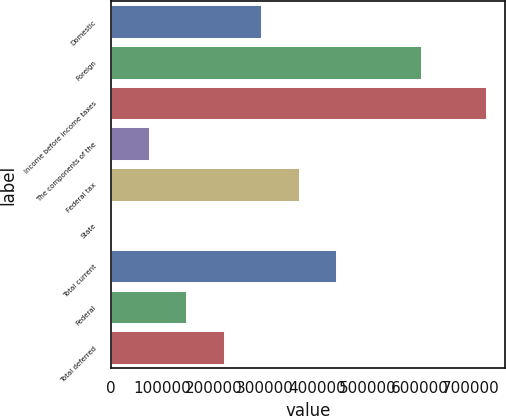Convert chart. <chart><loc_0><loc_0><loc_500><loc_500><bar_chart><fcel>Domestic<fcel>Foreign<fcel>Income before income taxes<fcel>The components of the<fcel>Federal tax<fcel>State<fcel>Total current<fcel>Federal<fcel>Total deferred<nl><fcel>291928<fcel>602261<fcel>729345<fcel>73218.9<fcel>364830<fcel>316<fcel>437733<fcel>146122<fcel>219025<nl></chart> 